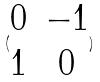Convert formula to latex. <formula><loc_0><loc_0><loc_500><loc_500>( \begin{matrix} 0 & - 1 \\ 1 & 0 \end{matrix} )</formula> 